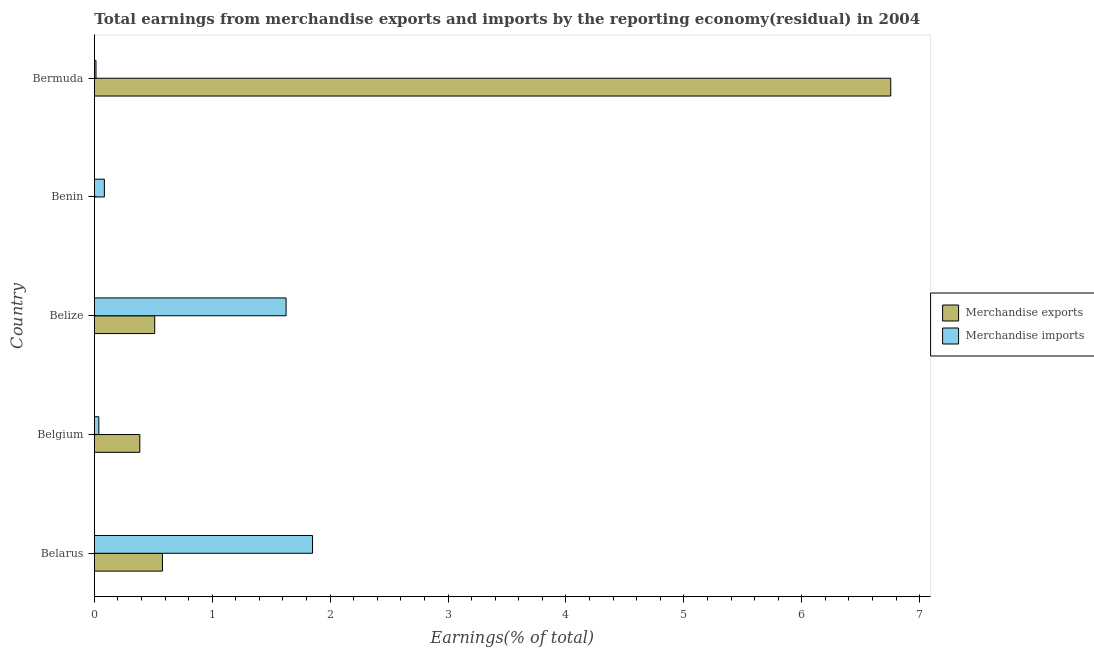How many different coloured bars are there?
Provide a short and direct response. 2. Are the number of bars per tick equal to the number of legend labels?
Provide a short and direct response. No. What is the label of the 5th group of bars from the top?
Your answer should be compact. Belarus. What is the earnings from merchandise imports in Belize?
Make the answer very short. 1.63. Across all countries, what is the maximum earnings from merchandise imports?
Keep it short and to the point. 1.85. In which country was the earnings from merchandise imports maximum?
Your response must be concise. Belarus. What is the total earnings from merchandise imports in the graph?
Offer a very short reply. 3.61. What is the difference between the earnings from merchandise imports in Belarus and that in Bermuda?
Your answer should be very brief. 1.84. What is the difference between the earnings from merchandise exports in Benin and the earnings from merchandise imports in Belize?
Your answer should be very brief. -1.63. What is the average earnings from merchandise imports per country?
Your answer should be very brief. 0.72. What is the difference between the earnings from merchandise imports and earnings from merchandise exports in Bermuda?
Offer a very short reply. -6.74. In how many countries, is the earnings from merchandise imports greater than 2.6 %?
Your response must be concise. 0. What is the ratio of the earnings from merchandise imports in Belarus to that in Belize?
Give a very brief answer. 1.14. Is the earnings from merchandise exports in Belarus less than that in Bermuda?
Your answer should be very brief. Yes. What is the difference between the highest and the second highest earnings from merchandise imports?
Ensure brevity in your answer.  0.22. What is the difference between the highest and the lowest earnings from merchandise exports?
Your answer should be very brief. 6.75. In how many countries, is the earnings from merchandise exports greater than the average earnings from merchandise exports taken over all countries?
Ensure brevity in your answer.  1. How many countries are there in the graph?
Offer a very short reply. 5. What is the difference between two consecutive major ticks on the X-axis?
Make the answer very short. 1. Are the values on the major ticks of X-axis written in scientific E-notation?
Provide a short and direct response. No. How are the legend labels stacked?
Ensure brevity in your answer.  Vertical. What is the title of the graph?
Your answer should be compact. Total earnings from merchandise exports and imports by the reporting economy(residual) in 2004. Does "Quality of trade" appear as one of the legend labels in the graph?
Ensure brevity in your answer.  No. What is the label or title of the X-axis?
Give a very brief answer. Earnings(% of total). What is the Earnings(% of total) in Merchandise exports in Belarus?
Provide a short and direct response. 0.58. What is the Earnings(% of total) in Merchandise imports in Belarus?
Your answer should be compact. 1.85. What is the Earnings(% of total) in Merchandise exports in Belgium?
Give a very brief answer. 0.39. What is the Earnings(% of total) of Merchandise imports in Belgium?
Offer a terse response. 0.04. What is the Earnings(% of total) of Merchandise exports in Belize?
Ensure brevity in your answer.  0.51. What is the Earnings(% of total) of Merchandise imports in Belize?
Provide a succinct answer. 1.63. What is the Earnings(% of total) in Merchandise exports in Benin?
Ensure brevity in your answer.  0. What is the Earnings(% of total) in Merchandise imports in Benin?
Make the answer very short. 0.09. What is the Earnings(% of total) in Merchandise exports in Bermuda?
Give a very brief answer. 6.75. What is the Earnings(% of total) in Merchandise imports in Bermuda?
Ensure brevity in your answer.  0.01. Across all countries, what is the maximum Earnings(% of total) in Merchandise exports?
Make the answer very short. 6.75. Across all countries, what is the maximum Earnings(% of total) of Merchandise imports?
Your answer should be very brief. 1.85. Across all countries, what is the minimum Earnings(% of total) in Merchandise imports?
Give a very brief answer. 0.01. What is the total Earnings(% of total) in Merchandise exports in the graph?
Your answer should be very brief. 8.23. What is the total Earnings(% of total) in Merchandise imports in the graph?
Give a very brief answer. 3.61. What is the difference between the Earnings(% of total) in Merchandise exports in Belarus and that in Belgium?
Offer a terse response. 0.19. What is the difference between the Earnings(% of total) in Merchandise imports in Belarus and that in Belgium?
Your answer should be compact. 1.81. What is the difference between the Earnings(% of total) in Merchandise exports in Belarus and that in Belize?
Give a very brief answer. 0.07. What is the difference between the Earnings(% of total) of Merchandise imports in Belarus and that in Belize?
Keep it short and to the point. 0.22. What is the difference between the Earnings(% of total) of Merchandise imports in Belarus and that in Benin?
Ensure brevity in your answer.  1.77. What is the difference between the Earnings(% of total) of Merchandise exports in Belarus and that in Bermuda?
Offer a very short reply. -6.18. What is the difference between the Earnings(% of total) of Merchandise imports in Belarus and that in Bermuda?
Keep it short and to the point. 1.84. What is the difference between the Earnings(% of total) of Merchandise exports in Belgium and that in Belize?
Offer a very short reply. -0.13. What is the difference between the Earnings(% of total) of Merchandise imports in Belgium and that in Belize?
Your answer should be compact. -1.59. What is the difference between the Earnings(% of total) in Merchandise imports in Belgium and that in Benin?
Your answer should be very brief. -0.05. What is the difference between the Earnings(% of total) in Merchandise exports in Belgium and that in Bermuda?
Keep it short and to the point. -6.37. What is the difference between the Earnings(% of total) of Merchandise imports in Belgium and that in Bermuda?
Your answer should be very brief. 0.02. What is the difference between the Earnings(% of total) of Merchandise imports in Belize and that in Benin?
Offer a terse response. 1.54. What is the difference between the Earnings(% of total) of Merchandise exports in Belize and that in Bermuda?
Your answer should be very brief. -6.24. What is the difference between the Earnings(% of total) of Merchandise imports in Belize and that in Bermuda?
Ensure brevity in your answer.  1.61. What is the difference between the Earnings(% of total) of Merchandise imports in Benin and that in Bermuda?
Give a very brief answer. 0.07. What is the difference between the Earnings(% of total) of Merchandise exports in Belarus and the Earnings(% of total) of Merchandise imports in Belgium?
Your response must be concise. 0.54. What is the difference between the Earnings(% of total) in Merchandise exports in Belarus and the Earnings(% of total) in Merchandise imports in Belize?
Ensure brevity in your answer.  -1.05. What is the difference between the Earnings(% of total) in Merchandise exports in Belarus and the Earnings(% of total) in Merchandise imports in Benin?
Provide a short and direct response. 0.49. What is the difference between the Earnings(% of total) of Merchandise exports in Belarus and the Earnings(% of total) of Merchandise imports in Bermuda?
Provide a short and direct response. 0.56. What is the difference between the Earnings(% of total) of Merchandise exports in Belgium and the Earnings(% of total) of Merchandise imports in Belize?
Your response must be concise. -1.24. What is the difference between the Earnings(% of total) of Merchandise exports in Belgium and the Earnings(% of total) of Merchandise imports in Benin?
Provide a succinct answer. 0.3. What is the difference between the Earnings(% of total) of Merchandise exports in Belgium and the Earnings(% of total) of Merchandise imports in Bermuda?
Your answer should be compact. 0.37. What is the difference between the Earnings(% of total) in Merchandise exports in Belize and the Earnings(% of total) in Merchandise imports in Benin?
Give a very brief answer. 0.43. What is the difference between the Earnings(% of total) in Merchandise exports in Belize and the Earnings(% of total) in Merchandise imports in Bermuda?
Provide a succinct answer. 0.5. What is the average Earnings(% of total) in Merchandise exports per country?
Provide a short and direct response. 1.65. What is the average Earnings(% of total) in Merchandise imports per country?
Make the answer very short. 0.72. What is the difference between the Earnings(% of total) of Merchandise exports and Earnings(% of total) of Merchandise imports in Belarus?
Offer a terse response. -1.27. What is the difference between the Earnings(% of total) in Merchandise exports and Earnings(% of total) in Merchandise imports in Belgium?
Give a very brief answer. 0.35. What is the difference between the Earnings(% of total) of Merchandise exports and Earnings(% of total) of Merchandise imports in Belize?
Your response must be concise. -1.11. What is the difference between the Earnings(% of total) in Merchandise exports and Earnings(% of total) in Merchandise imports in Bermuda?
Your answer should be compact. 6.74. What is the ratio of the Earnings(% of total) in Merchandise exports in Belarus to that in Belgium?
Make the answer very short. 1.5. What is the ratio of the Earnings(% of total) of Merchandise imports in Belarus to that in Belgium?
Your answer should be very brief. 48.57. What is the ratio of the Earnings(% of total) in Merchandise exports in Belarus to that in Belize?
Your answer should be compact. 1.13. What is the ratio of the Earnings(% of total) in Merchandise imports in Belarus to that in Belize?
Make the answer very short. 1.14. What is the ratio of the Earnings(% of total) of Merchandise imports in Belarus to that in Benin?
Ensure brevity in your answer.  21.72. What is the ratio of the Earnings(% of total) in Merchandise exports in Belarus to that in Bermuda?
Keep it short and to the point. 0.09. What is the ratio of the Earnings(% of total) of Merchandise imports in Belarus to that in Bermuda?
Make the answer very short. 132.76. What is the ratio of the Earnings(% of total) in Merchandise exports in Belgium to that in Belize?
Make the answer very short. 0.75. What is the ratio of the Earnings(% of total) in Merchandise imports in Belgium to that in Belize?
Your answer should be very brief. 0.02. What is the ratio of the Earnings(% of total) of Merchandise imports in Belgium to that in Benin?
Offer a terse response. 0.45. What is the ratio of the Earnings(% of total) in Merchandise exports in Belgium to that in Bermuda?
Offer a very short reply. 0.06. What is the ratio of the Earnings(% of total) of Merchandise imports in Belgium to that in Bermuda?
Make the answer very short. 2.73. What is the ratio of the Earnings(% of total) in Merchandise imports in Belize to that in Benin?
Keep it short and to the point. 19.09. What is the ratio of the Earnings(% of total) of Merchandise exports in Belize to that in Bermuda?
Your response must be concise. 0.08. What is the ratio of the Earnings(% of total) of Merchandise imports in Belize to that in Bermuda?
Make the answer very short. 116.66. What is the ratio of the Earnings(% of total) in Merchandise imports in Benin to that in Bermuda?
Your response must be concise. 6.11. What is the difference between the highest and the second highest Earnings(% of total) of Merchandise exports?
Give a very brief answer. 6.18. What is the difference between the highest and the second highest Earnings(% of total) of Merchandise imports?
Offer a very short reply. 0.22. What is the difference between the highest and the lowest Earnings(% of total) of Merchandise exports?
Your answer should be very brief. 6.75. What is the difference between the highest and the lowest Earnings(% of total) of Merchandise imports?
Make the answer very short. 1.84. 